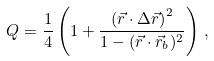<formula> <loc_0><loc_0><loc_500><loc_500>Q = \frac { 1 } { 4 } \left ( 1 + \frac { \left ( \vec { r } \cdot \Delta \vec { r } \right ) ^ { 2 } } { 1 - ( \vec { r } \cdot \vec { r } _ { b } ) ^ { 2 } } \right ) \, ,</formula> 